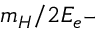Convert formula to latex. <formula><loc_0><loc_0><loc_500><loc_500>m _ { H } / 2 E _ { e ^ { - } }</formula> 